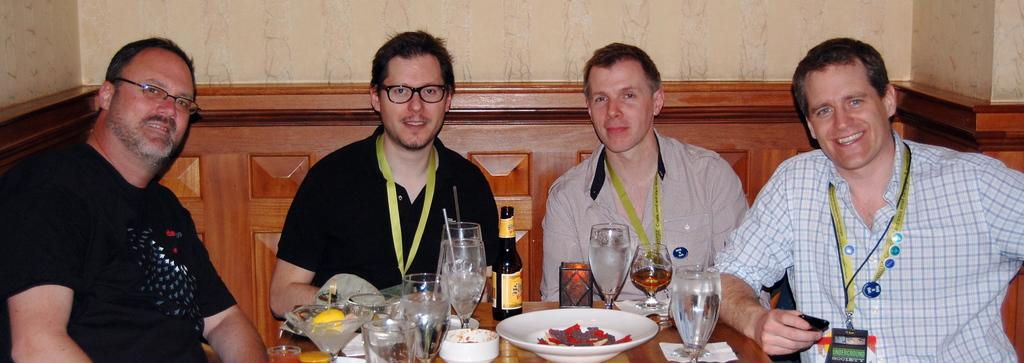What type of furniture is in the image? There is a table in the image. What items are placed on the table? Glasses, bowls, plates, cups, and bottles are present on the table. What else can be seen on the table? Eatables are visible on the table. How many people are sitting around the table? There are 4 persons sitting around the table. What type of brake is visible on the table in the image? There is no brake present on the table in the image. Can you explain the existence of the table in the image? The existence of the table in the image is evident from the fact that it is mentioned as a part of the image's content. 